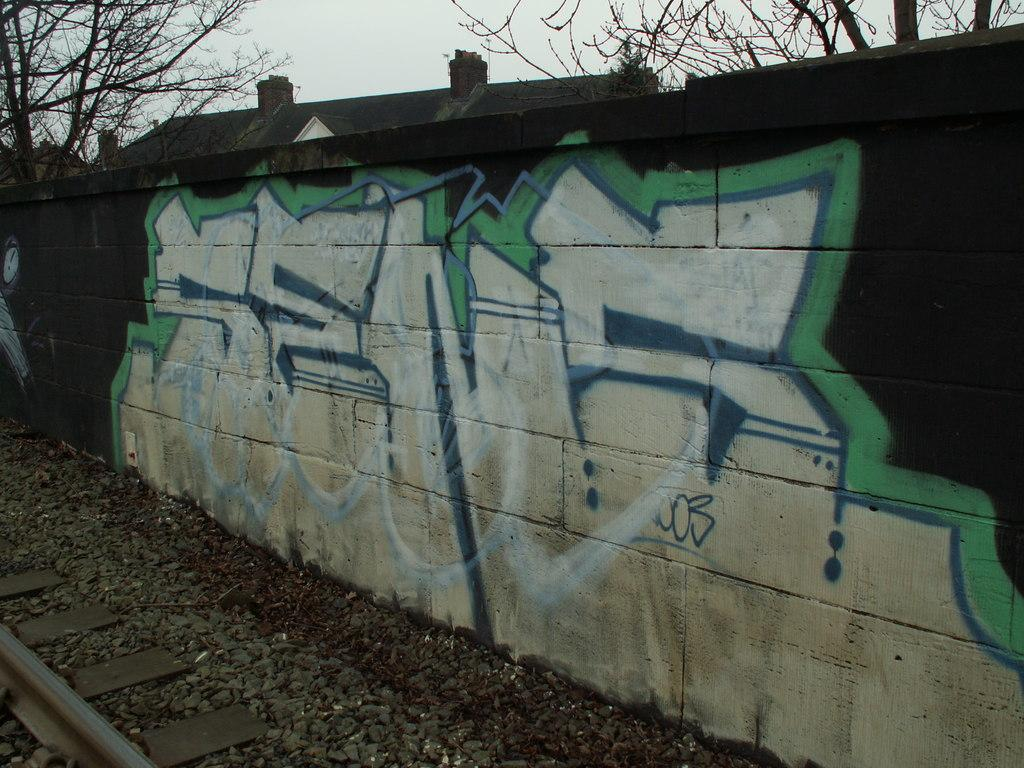What is depicted on the wall in the image? There is graffiti on a wall in the image. What type of structure is present in the image? There is a building in the image. What type of vegetation can be seen in the image? There are trees in the image. What type of transportation infrastructure is visible in the image? There is a railway track in the image. What type of ground surface is present in the image? There are stones in the image. What is visible in the sky in the image? The sky is visible in the image. Can you hear the whistle of the train in the image? There is no sound present in the image, so it is not possible to hear a train whistle. What type of plants are growing on the railway track in the image? There are no plants growing on the railway track in the image; it is made of stones. 